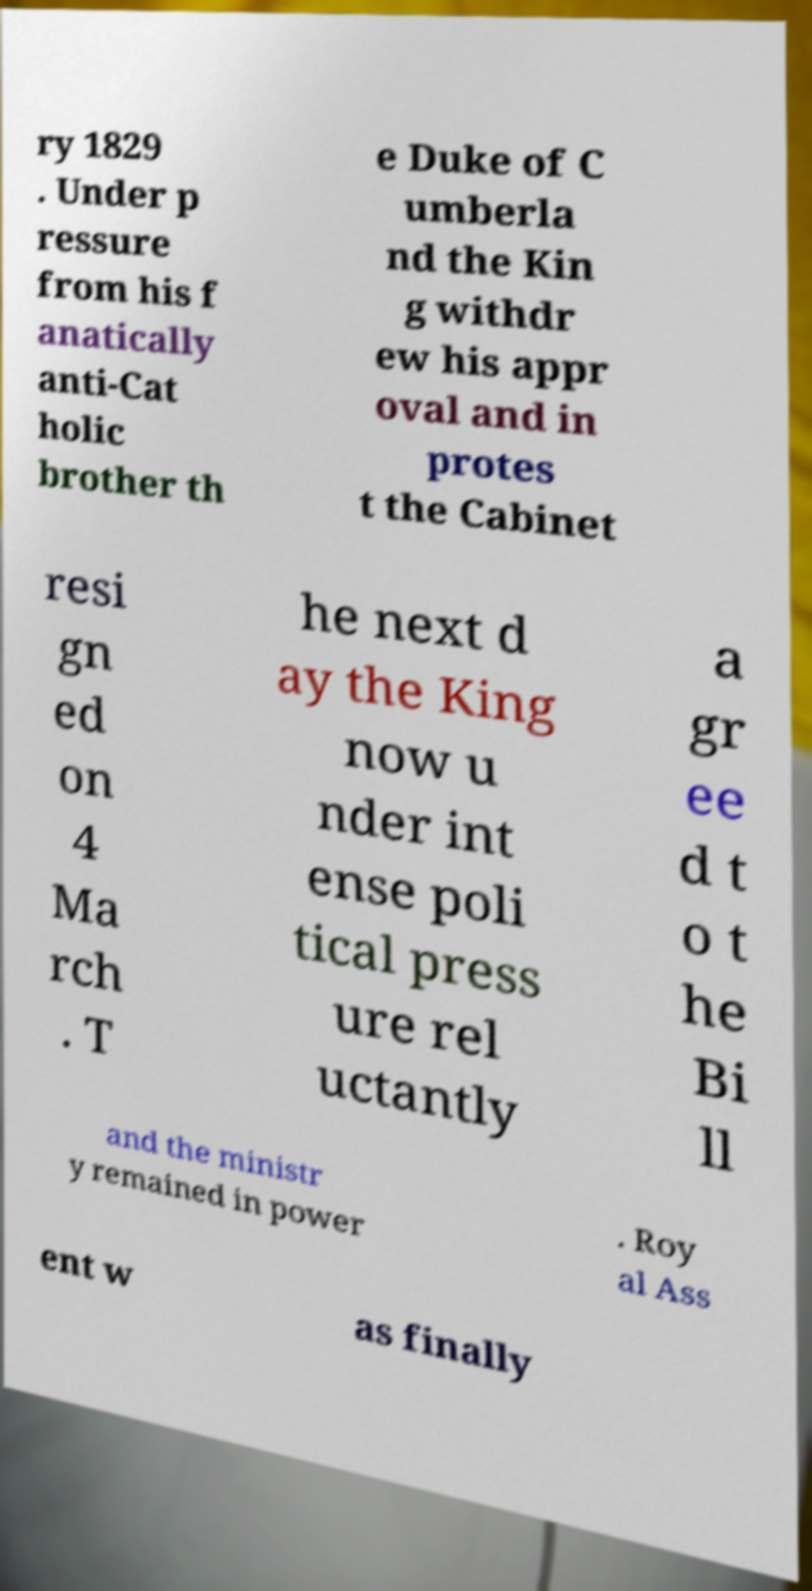Can you accurately transcribe the text from the provided image for me? ry 1829 . Under p ressure from his f anatically anti-Cat holic brother th e Duke of C umberla nd the Kin g withdr ew his appr oval and in protes t the Cabinet resi gn ed on 4 Ma rch . T he next d ay the King now u nder int ense poli tical press ure rel uctantly a gr ee d t o t he Bi ll and the ministr y remained in power . Roy al Ass ent w as finally 